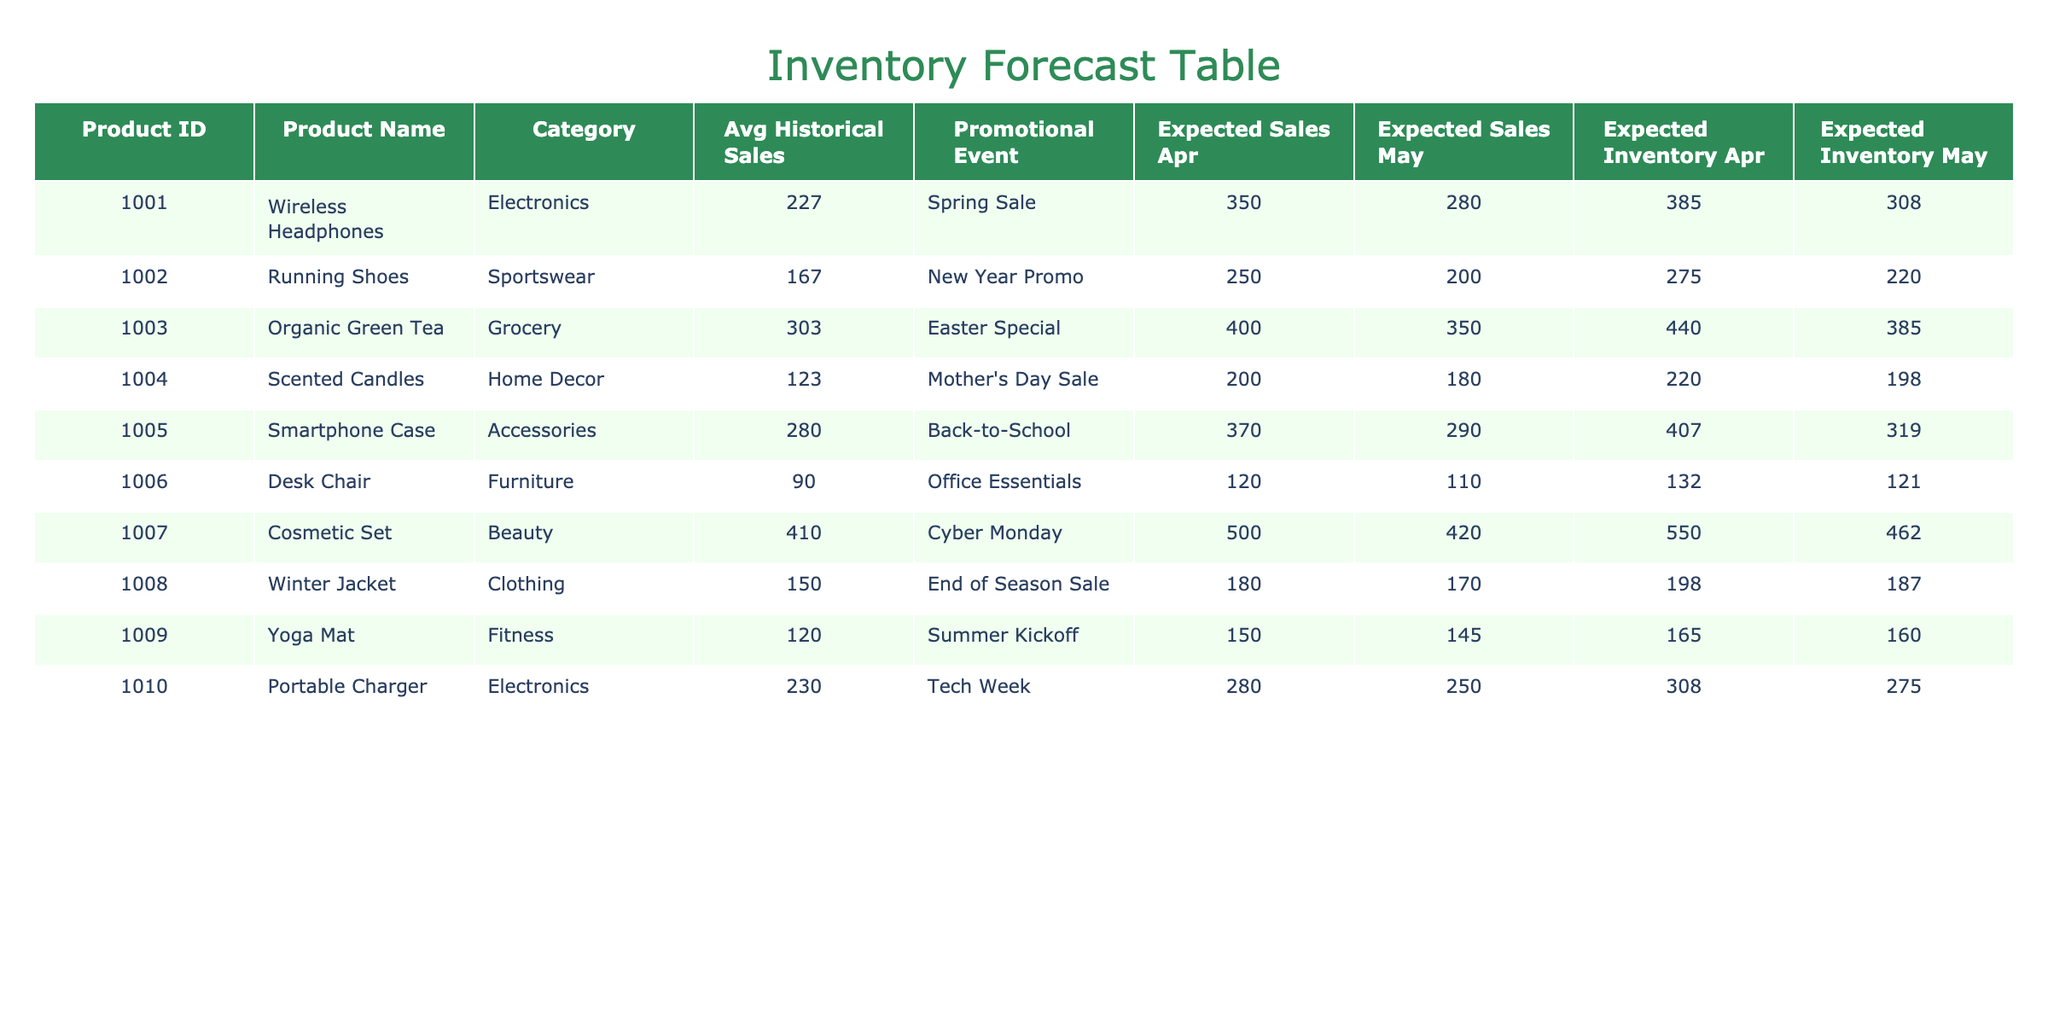What is the average historical sales for the Wireless Headphones? The historical sales for the Wireless Headphones in January, February, and March are 200, 180, and 300 respectively. To find the average, we sum these three values: 200 + 180 + 300 = 680. Then we divide this sum by the number of months, which is 3. So, the average is 680 / 3 = 226.67, which rounds to 227.
Answer: 227 Which product has the highest expected sales in April? Looking at the expected sales for April for all products, the values are 350 for Wireless Headphones, 250 for Running Shoes, 400 for Organic Green Tea, 200 for Scented Candles, 370 for Smartphone Case, 120 for Desk Chair, 500 for Cosmetic Set, 180 for Winter Jacket, 150 for Yoga Mat, and 280 for Portable Charger. The highest number is 500, which corresponds to the Cosmetic Set.
Answer: Cosmetic Set Is the expected inventory for Running Shoes higher than that for Desk Chair? The expected inventory for Running Shoes is calculated as Expected Sales in April (250) * 1.1 = 275, and for Desk Chair, it is 120 * 1.1 = 132. Comparing these two values, 275 is greater than 132.
Answer: Yes Does the product with the highest historical sales also have the highest expected sales in April? The product with the highest historical sales is the Cosmetic Set with 450 in March, while the highest expected sales in April is 500, also attributed to the Cosmetic Set. Since both metrics correspond to the same product, we conclude that yes, it does.
Answer: Yes Which category has the lowest expected sales in May and what is that amount? Reviewing the expected sales for May across categories, we see that the amounts are: Electronics (280), Sportswear (200), Grocery (350), Home Decor (180), Accessories (290), Furniture (110), Beauty (420), Clothing (170), Fitness (145), and Tech (250). The lowest expected sales in May is for the Desk Chair at 110.
Answer: Furniture, 110 What is the difference between the expected sales of Organic Green Tea and Winter Jacket in April? The expected sales for Organic Green Tea in April is 400, and for Winter Jacket, it is 180. To find the difference, we subtract: 400 - 180 = 220.
Answer: 220 